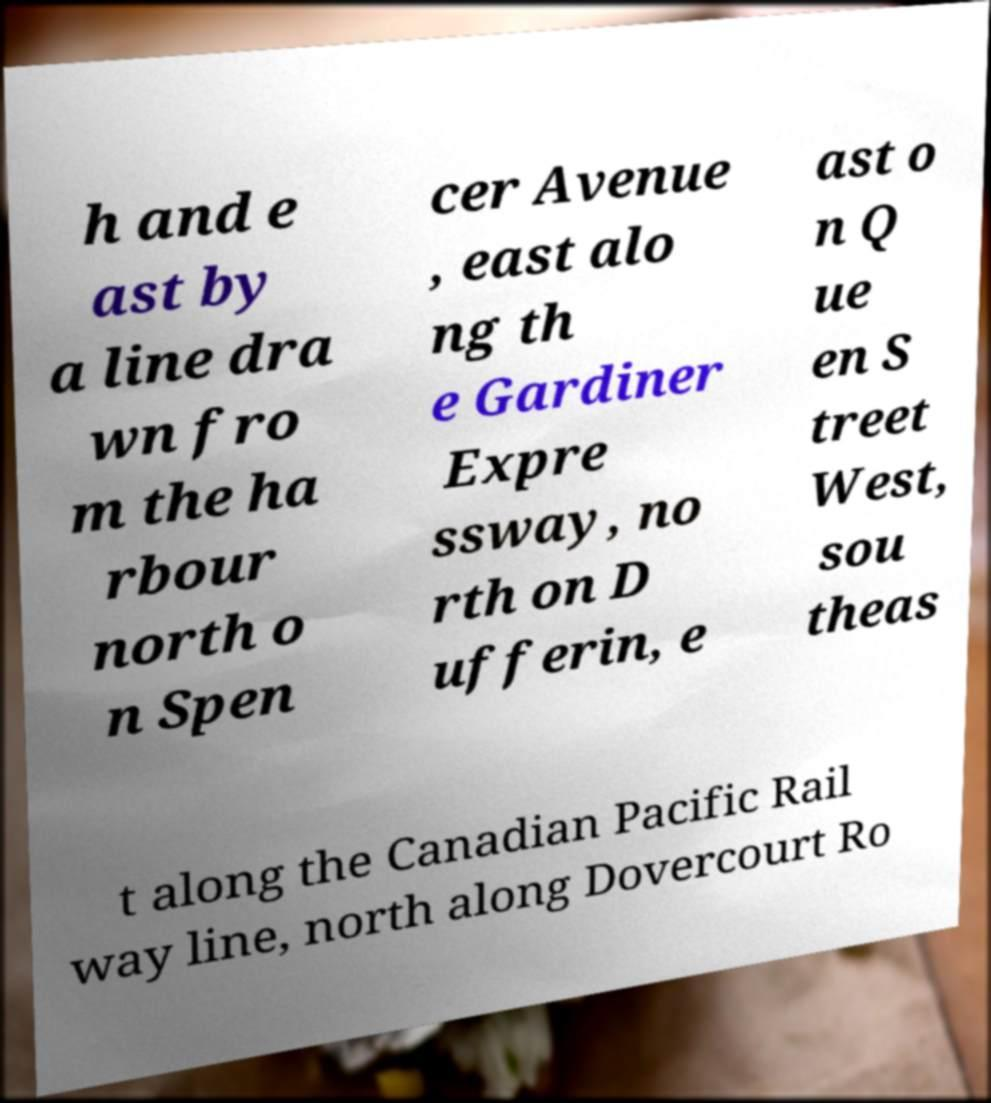Can you read and provide the text displayed in the image?This photo seems to have some interesting text. Can you extract and type it out for me? h and e ast by a line dra wn fro m the ha rbour north o n Spen cer Avenue , east alo ng th e Gardiner Expre ssway, no rth on D ufferin, e ast o n Q ue en S treet West, sou theas t along the Canadian Pacific Rail way line, north along Dovercourt Ro 